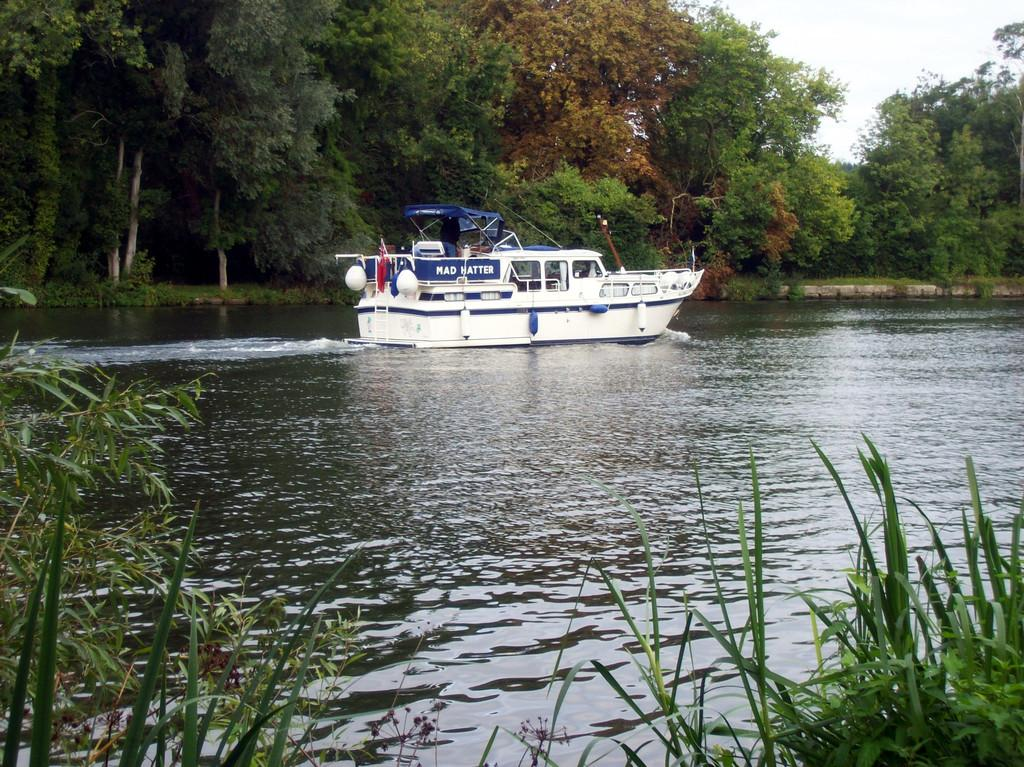What is the main subject of the image? The main subject of the image is a boat. Where is the boat located in the image? The boat is on the water surface in the image. What can be seen in the background of the image? There are trees in the background of the image. What type of vegetation is at the bottom of the image? There is grass at the bottom of the image. What is visible at the top of the image? The sky is visible at the top of the image. What example of a substance can be seen dissolving in the water in the image? There is no substance dissolving in the water in the image; it only features a boat on the water surface. How old is the son of the person who took the image? There is no information about the person who took the image or their son in the provided facts, so it cannot be determined. 